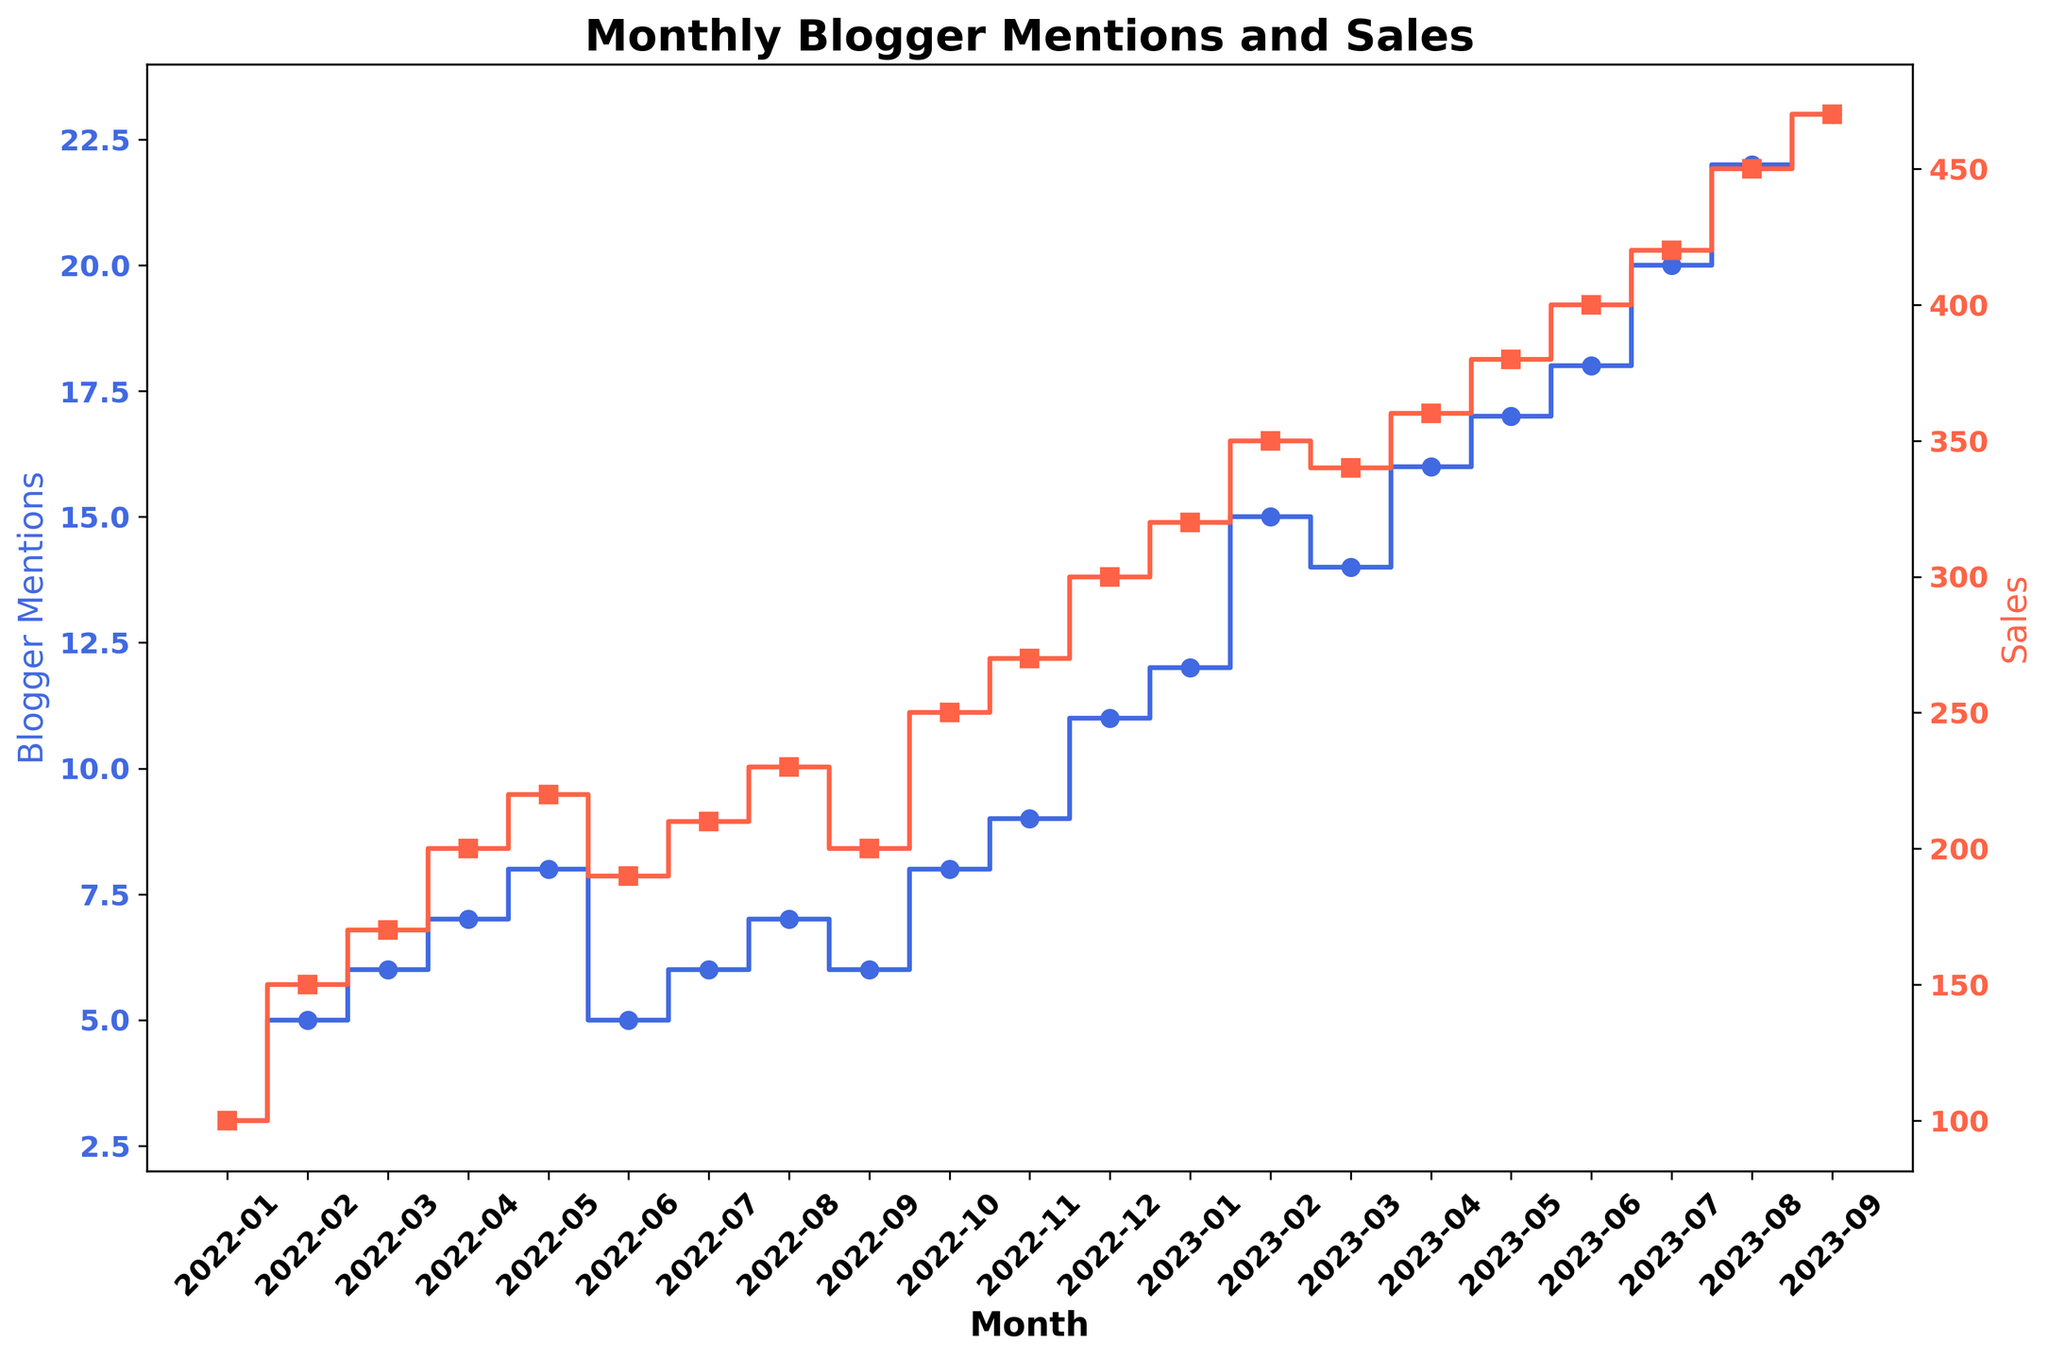What is the general trend of blogger mentions over the given period? The figure shows that blogger mentions consistently increase from month to month, with only minor fluctuations. From 3 mentions in January 2022 to 23 mentions in September 2023, the overall trend is a significant upward trajectory.
Answer: Increasing Which month shows the highest sales, and how many sales are recorded for that month? The highest sales are recorded in September 2023, as indicated by the tallest stairs on the graph in the Sales line, showing 470 sales.
Answer: September 2023, 470 Is there any month where blogger mentions remained the same compared to the previous month? If yes, which months? Looking at the stairs plot, there are no horizontal steps for blogger mentions, which means that mentions increased or decreased every month. Hence, mentions did not remain the same in any two consecutive months.
Answer: No How does the sales number compare between January 2022 and January 2023? In January 2022, sales were 100, whereas in January 2023, sales were 320. By subtracting, the difference is 320 - 100 = 220, indicating that sales have more than tripled.
Answer: January 2023 is 220 more than January 2022 Compare the increase in blogger mentions from February to March 2023 with the increase from March to April 2023. Which increase is greater? From February to March 2023, blogger mentions increased from 15 to 14 (by 1). From March to April 2023, they increased from 14 to 16 (by 2). Hence, the increase in mentions from March to April 2023 is greater.
Answer: March to April 2023 increase is greater During which months does the sales line show the steepest upward trend? The sales line shows the steepest upward trend from January 2023 to February 2023 and from August 2023 to September 2023, where sales increased significantly in the shortest timeframe.
Answer: January to February 2023 and August to September 2023 What is the relationship between blogger mentions and sales in December 2022? In December 2022, there are 11 blogger mentions and 300 sales. This shows a positive correlation as an increase in mentions correlates with higher sales.
Answer: Positive correlation How much did the sales increase from January 2023 to February 2023? Sales in January 2023 were 320, and in February 2023, they were 350. The increase is 350 - 320 = 30.
Answer: 30 Compare the sales numbers for May 2022 and May 2023. What is the difference? Sales in May 2022 were 220, and in May 2023, they were 380. The difference is 380 - 220 = 160.
Answer: 160 What color represents blogger mentions in the plot? The blogger mentions are represented by the royal blue color in the plot.
Answer: Royal blue 